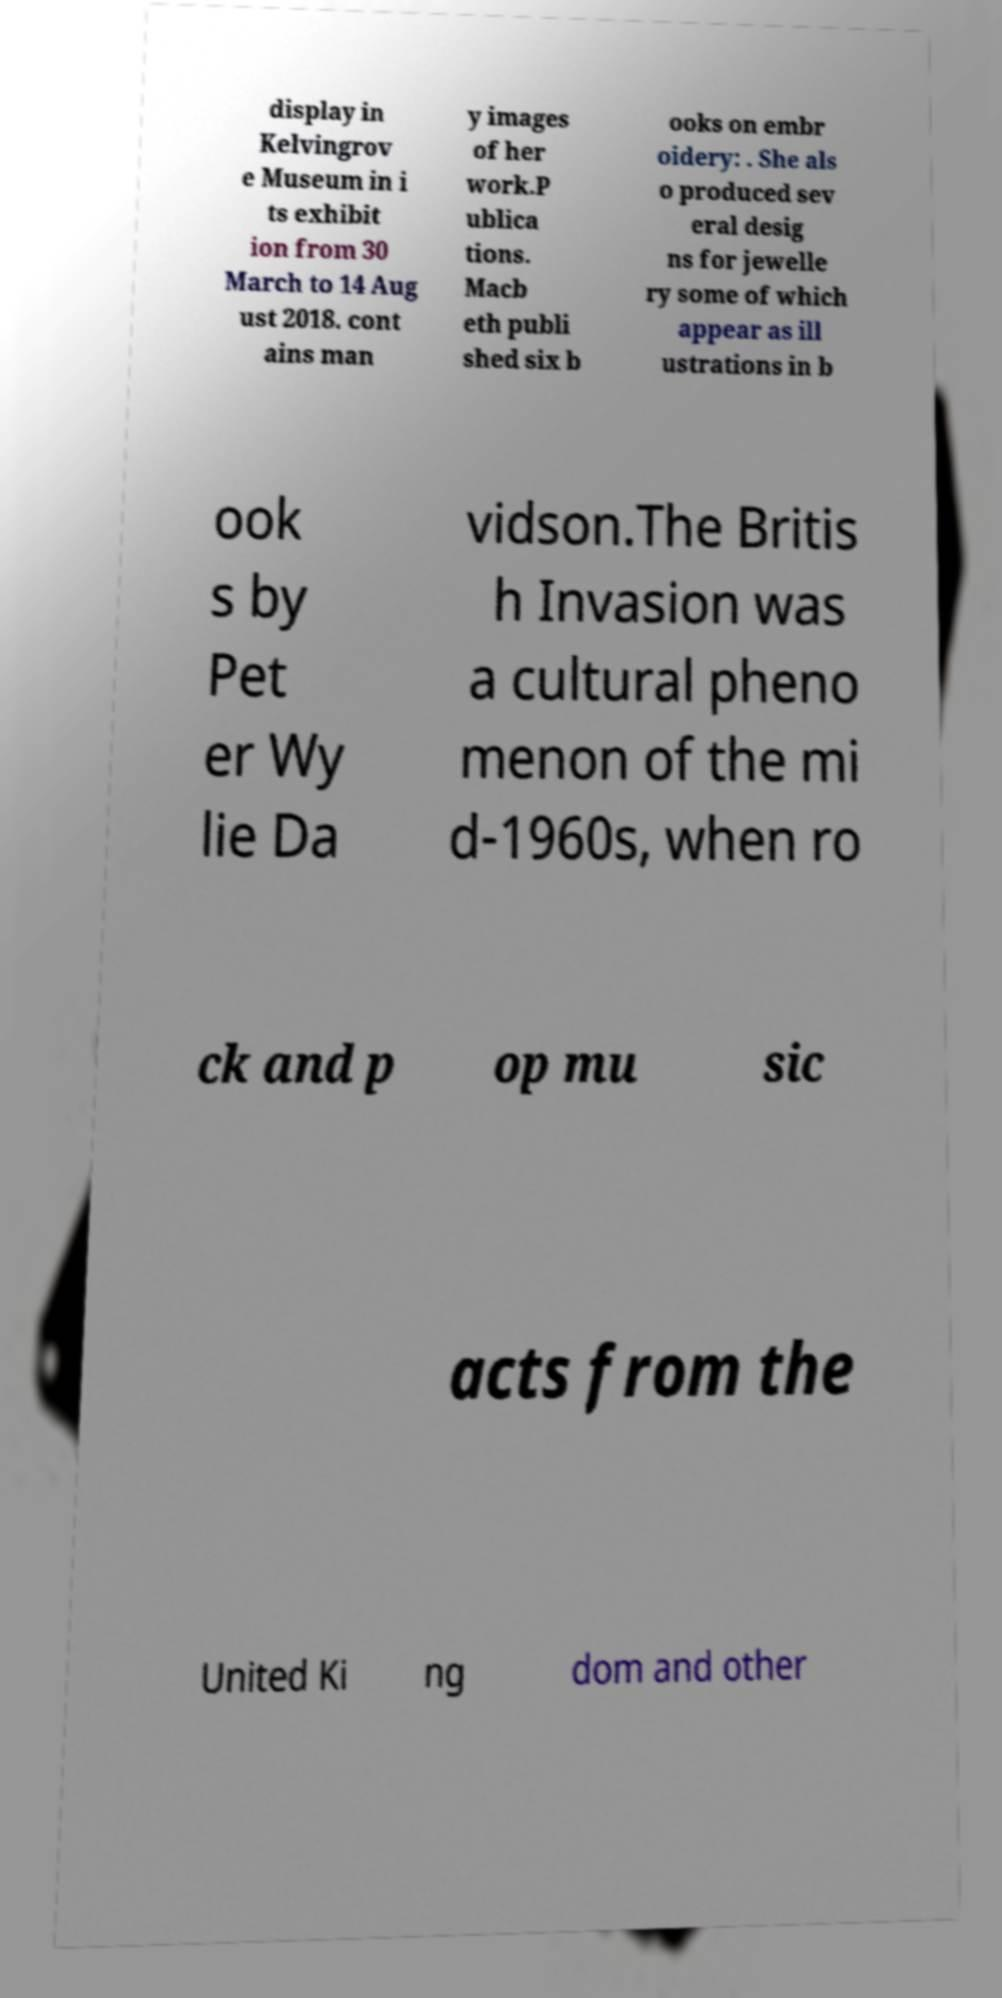For documentation purposes, I need the text within this image transcribed. Could you provide that? display in Kelvingrov e Museum in i ts exhibit ion from 30 March to 14 Aug ust 2018. cont ains man y images of her work.P ublica tions. Macb eth publi shed six b ooks on embr oidery: . She als o produced sev eral desig ns for jewelle ry some of which appear as ill ustrations in b ook s by Pet er Wy lie Da vidson.The Britis h Invasion was a cultural pheno menon of the mi d-1960s, when ro ck and p op mu sic acts from the United Ki ng dom and other 